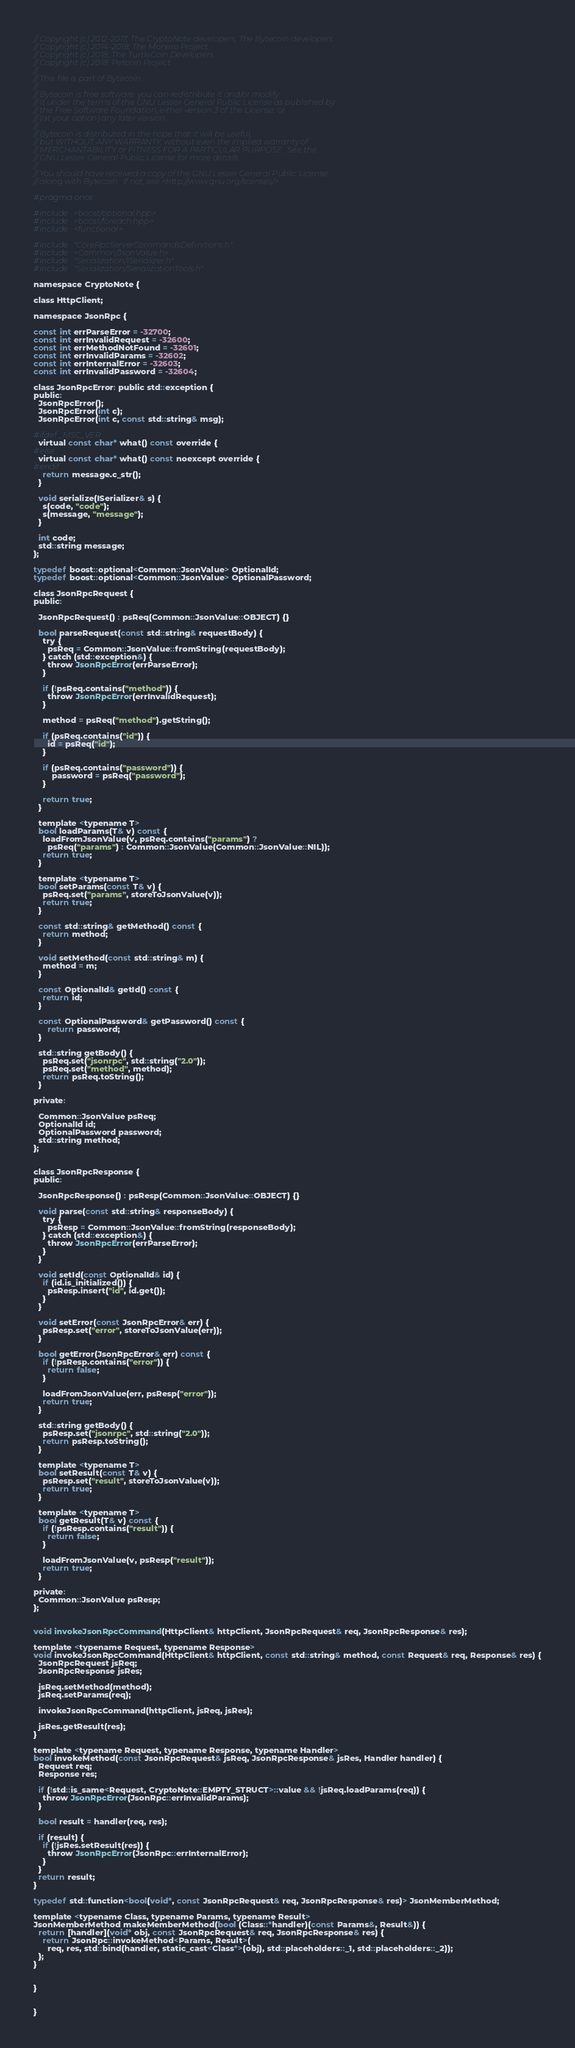<code> <loc_0><loc_0><loc_500><loc_500><_C_>// Copyright (c) 2012-2017, The CryptoNote developers, The Bytecoin developers
// Copyright (c) 2014-2018, The Monero Project
// Copyright (c) 2018, The TurtleCoin Developers
// Copyright (c) 2018, Petcoin Project
//
// This file is part of Bytecoin.
//
// Bytecoin is free software: you can redistribute it and/or modify
// it under the terms of the GNU Lesser General Public License as published by
// the Free Software Foundation, either version 3 of the License, or
// (at your option) any later version.
//
// Bytecoin is distributed in the hope that it will be useful,
// but WITHOUT ANY WARRANTY; without even the implied warranty of
// MERCHANTABILITY or FITNESS FOR A PARTICULAR PURPOSE.  See the
// GNU Lesser General Public License for more details.
//
// You should have received a copy of the GNU Lesser General Public License
// along with Bytecoin.  If not, see <http://www.gnu.org/licenses/>.

#pragma once

#include <boost/optional.hpp>
#include <boost/foreach.hpp>
#include <functional>

#include "CoreRpcServerCommandsDefinitions.h"
#include <Common/JsonValue.h>
#include "Serialization/ISerializer.h"
#include "Serialization/SerializationTools.h"

namespace CryptoNote {

class HttpClient;
  
namespace JsonRpc {

const int errParseError = -32700;
const int errInvalidRequest = -32600;
const int errMethodNotFound = -32601;
const int errInvalidParams = -32602;
const int errInternalError = -32603;
const int errInvalidPassword = -32604;

class JsonRpcError: public std::exception {
public:
  JsonRpcError();
  JsonRpcError(int c);
  JsonRpcError(int c, const std::string& msg);

#ifdef _MSC_VER
  virtual const char* what() const override {
#else
  virtual const char* what() const noexcept override {
#endif
    return message.c_str();
  }

  void serialize(ISerializer& s) {
    s(code, "code");
    s(message, "message");
  }

  int code;
  std::string message;
};

typedef boost::optional<Common::JsonValue> OptionalId;
typedef boost::optional<Common::JsonValue> OptionalPassword;

class JsonRpcRequest {
public:
  
  JsonRpcRequest() : psReq(Common::JsonValue::OBJECT) {}

  bool parseRequest(const std::string& requestBody) {
    try {
      psReq = Common::JsonValue::fromString(requestBody);
    } catch (std::exception&) {
      throw JsonRpcError(errParseError);
    }

    if (!psReq.contains("method")) {
      throw JsonRpcError(errInvalidRequest);
    }

    method = psReq("method").getString();

    if (psReq.contains("id")) {
      id = psReq("id");
    }
	
	if (psReq.contains("password")) {
		password = psReq("password");
    }

    return true;
  }

  template <typename T>
  bool loadParams(T& v) const {
    loadFromJsonValue(v, psReq.contains("params") ? 
      psReq("params") : Common::JsonValue(Common::JsonValue::NIL));
    return true;
  }

  template <typename T>
  bool setParams(const T& v) {
    psReq.set("params", storeToJsonValue(v));
    return true;
  }

  const std::string& getMethod() const {
    return method;
  }

  void setMethod(const std::string& m) {
    method = m;
  }

  const OptionalId& getId() const {
    return id;
  }
  
  const OptionalPassword& getPassword() const {
	  return password;
  }

  std::string getBody() {
    psReq.set("jsonrpc", std::string("2.0"));
    psReq.set("method", method);
    return psReq.toString();
  }

private:

  Common::JsonValue psReq;
  OptionalId id;
  OptionalPassword password;
  std::string method;
};


class JsonRpcResponse {
public:

  JsonRpcResponse() : psResp(Common::JsonValue::OBJECT) {}

  void parse(const std::string& responseBody) {
    try {
      psResp = Common::JsonValue::fromString(responseBody);
    } catch (std::exception&) {
      throw JsonRpcError(errParseError);
    }
  }

  void setId(const OptionalId& id) {
    if (id.is_initialized()) {
      psResp.insert("id", id.get());
    }
  }

  void setError(const JsonRpcError& err) {
    psResp.set("error", storeToJsonValue(err));
  }

  bool getError(JsonRpcError& err) const {
    if (!psResp.contains("error")) {
      return false;
    }

    loadFromJsonValue(err, psResp("error"));
    return true;
  }

  std::string getBody() {
    psResp.set("jsonrpc", std::string("2.0"));
    return psResp.toString();
  }

  template <typename T>
  bool setResult(const T& v) {
    psResp.set("result", storeToJsonValue(v));
    return true;
  }

  template <typename T>
  bool getResult(T& v) const {
    if (!psResp.contains("result")) {
      return false;
    }

    loadFromJsonValue(v, psResp("result"));
    return true;
  }

private:
  Common::JsonValue psResp;
};


void invokeJsonRpcCommand(HttpClient& httpClient, JsonRpcRequest& req, JsonRpcResponse& res);

template <typename Request, typename Response>
void invokeJsonRpcCommand(HttpClient& httpClient, const std::string& method, const Request& req, Response& res) {
  JsonRpcRequest jsReq;
  JsonRpcResponse jsRes;

  jsReq.setMethod(method);
  jsReq.setParams(req);

  invokeJsonRpcCommand(httpClient, jsReq, jsRes);

  jsRes.getResult(res);
}

template <typename Request, typename Response, typename Handler>
bool invokeMethod(const JsonRpcRequest& jsReq, JsonRpcResponse& jsRes, Handler handler) {
  Request req;
  Response res;

  if (!std::is_same<Request, CryptoNote::EMPTY_STRUCT>::value && !jsReq.loadParams(req)) {
    throw JsonRpcError(JsonRpc::errInvalidParams);
  }

  bool result = handler(req, res);

  if (result) {
    if (!jsRes.setResult(res)) {
      throw JsonRpcError(JsonRpc::errInternalError);
    }
  }
  return result;
}

typedef std::function<bool(void*, const JsonRpcRequest& req, JsonRpcResponse& res)> JsonMemberMethod;

template <typename Class, typename Params, typename Result>
JsonMemberMethod makeMemberMethod(bool (Class::*handler)(const Params&, Result&)) {
  return [handler](void* obj, const JsonRpcRequest& req, JsonRpcResponse& res) {
    return JsonRpc::invokeMethod<Params, Result>(
      req, res, std::bind(handler, static_cast<Class*>(obj), std::placeholders::_1, std::placeholders::_2));
  };
}


}


}
</code> 